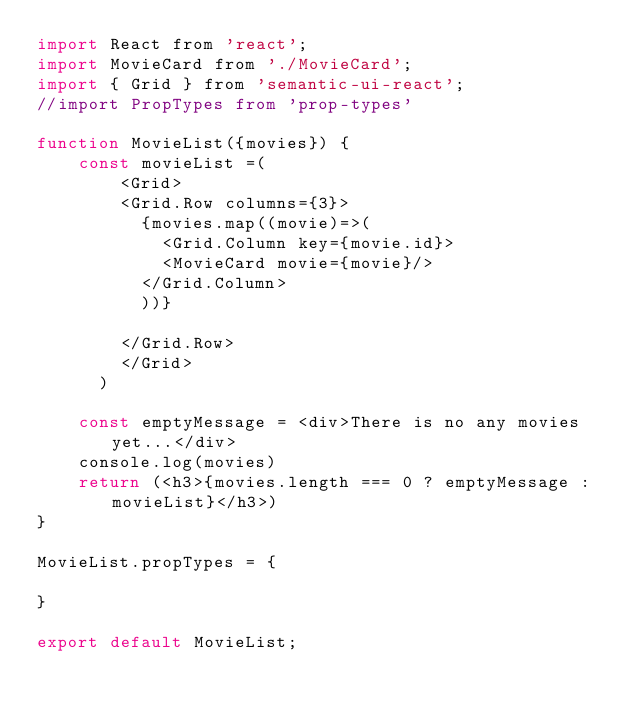<code> <loc_0><loc_0><loc_500><loc_500><_JavaScript_>import React from 'react';
import MovieCard from './MovieCard';
import { Grid } from 'semantic-ui-react';
//import PropTypes from 'prop-types'

function MovieList({movies}) {
    const movieList =(
        <Grid>
        <Grid.Row columns={3}>
          {movies.map((movie)=>(
            <Grid.Column key={movie.id}>
            <MovieCard movie={movie}/>
          </Grid.Column>
          ))}
          
        </Grid.Row>
        </Grid>
      )  
    
    const emptyMessage = <div>There is no any movies yet...</div>
    console.log(movies)
    return (<h3>{movies.length === 0 ? emptyMessage : movieList}</h3>)
}

MovieList.propTypes = {

}

export default MovieList;


</code> 